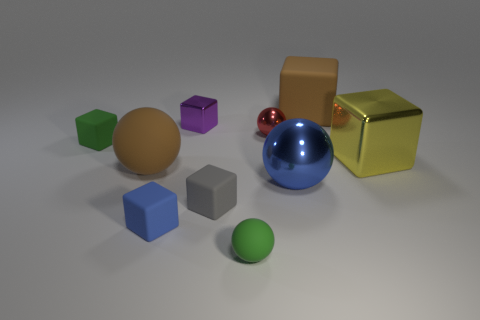Subtract 1 blocks. How many blocks are left? 5 Subtract all gray blocks. How many blocks are left? 5 Subtract all big brown matte blocks. How many blocks are left? 5 Subtract all red blocks. Subtract all blue cylinders. How many blocks are left? 6 Subtract all blocks. How many objects are left? 4 Add 6 yellow objects. How many yellow objects are left? 7 Add 9 tiny red things. How many tiny red things exist? 10 Subtract 1 blue cubes. How many objects are left? 9 Subtract all large brown spheres. Subtract all large blue balls. How many objects are left? 8 